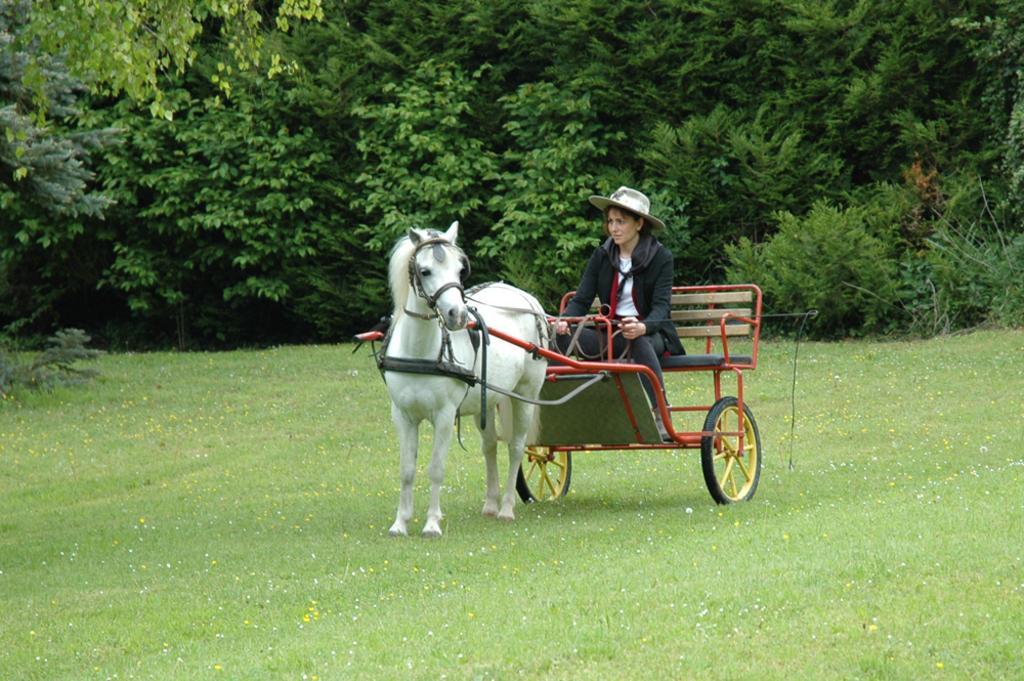In one or two sentences, can you explain what this image depicts? In this picture we can see a woman sitting in a horse cart, at the bottom there is grass, we can see trees in the background, this woman wore a cap. 